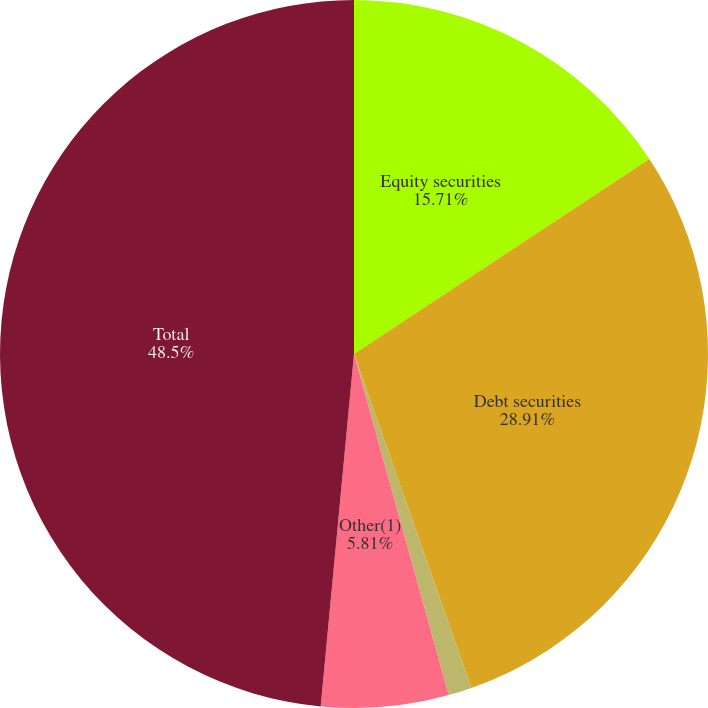Convert chart to OTSL. <chart><loc_0><loc_0><loc_500><loc_500><pie_chart><fcel>Equity securities<fcel>Debt securities<fcel>Real estate<fcel>Other(1)<fcel>Total<nl><fcel>15.71%<fcel>28.91%<fcel>1.07%<fcel>5.81%<fcel>48.5%<nl></chart> 